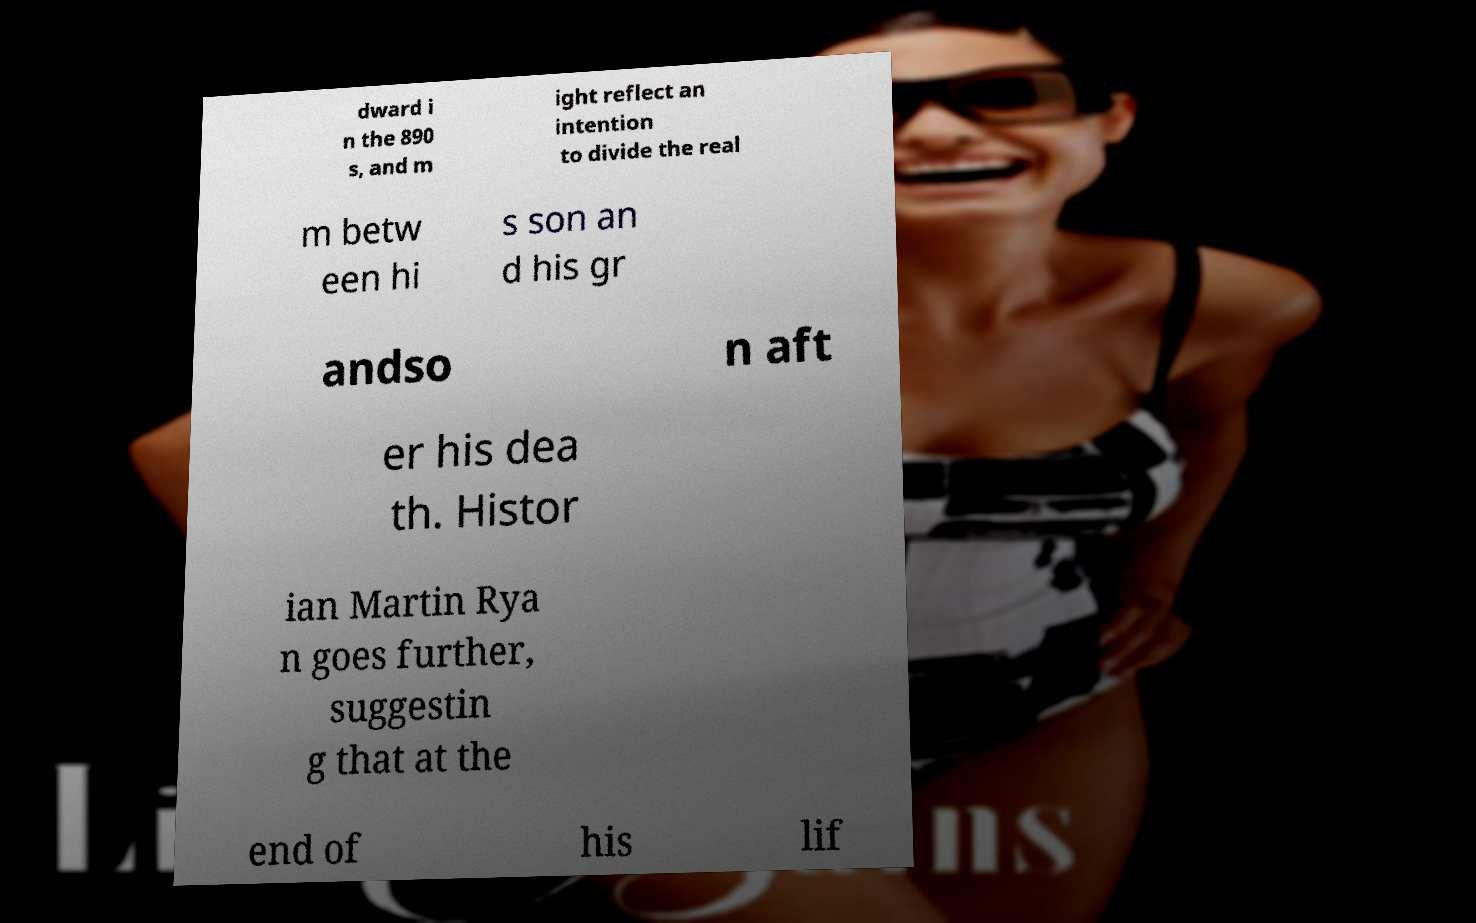Could you assist in decoding the text presented in this image and type it out clearly? dward i n the 890 s, and m ight reflect an intention to divide the real m betw een hi s son an d his gr andso n aft er his dea th. Histor ian Martin Rya n goes further, suggestin g that at the end of his lif 